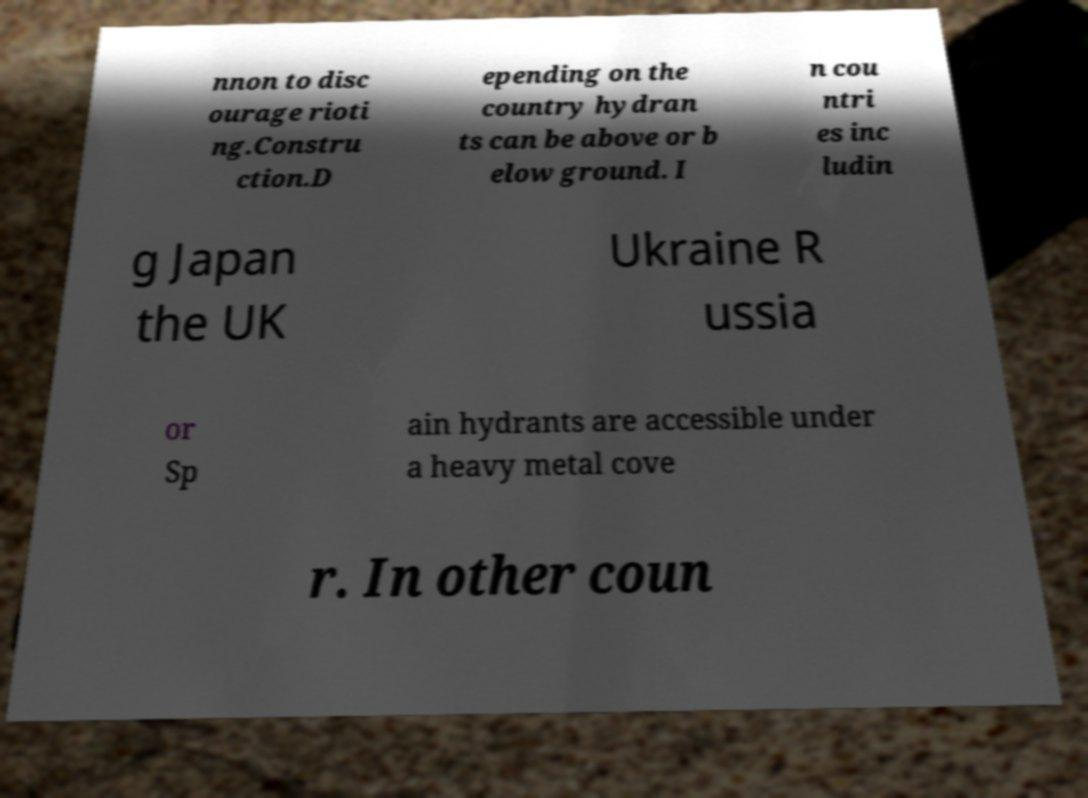There's text embedded in this image that I need extracted. Can you transcribe it verbatim? nnon to disc ourage rioti ng.Constru ction.D epending on the country hydran ts can be above or b elow ground. I n cou ntri es inc ludin g Japan the UK Ukraine R ussia or Sp ain hydrants are accessible under a heavy metal cove r. In other coun 